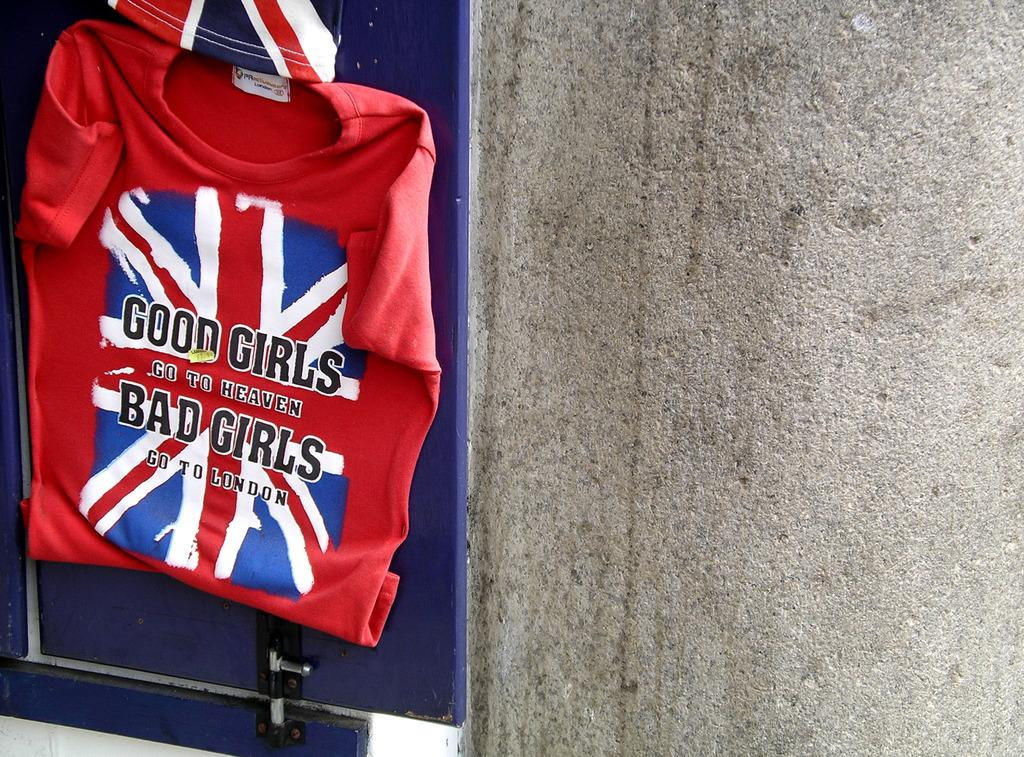<image>
Write a terse but informative summary of the picture. A red shirt with the British flag says Good Girls go to heaven Bad Girls go to London and is hanging on a wall. 